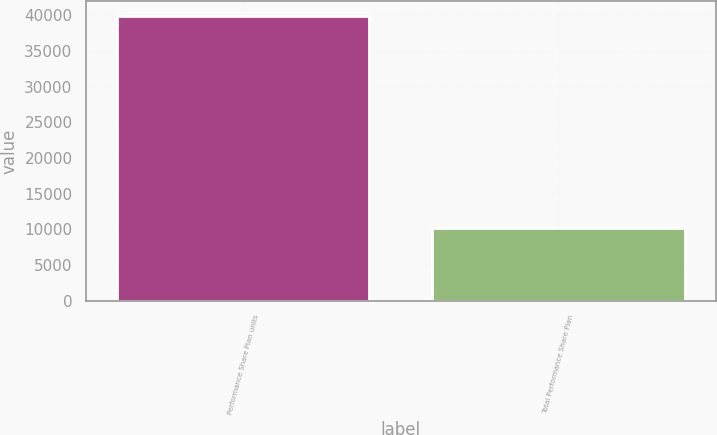Convert chart to OTSL. <chart><loc_0><loc_0><loc_500><loc_500><bar_chart><fcel>Performance Share Plan units<fcel>Total Performance Share Plan<nl><fcel>39977<fcel>10133<nl></chart> 